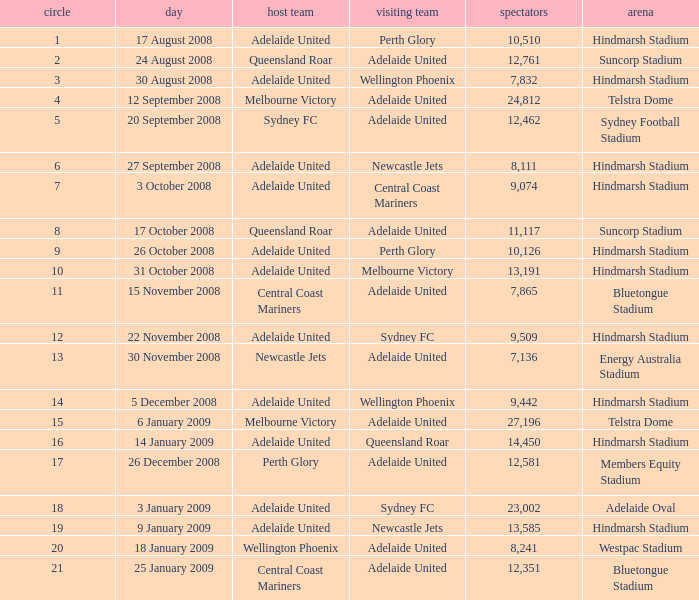What is the least round for the game played at Members Equity Stadium in from of 12,581 people? None. 